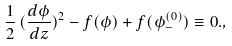Convert formula to latex. <formula><loc_0><loc_0><loc_500><loc_500>\frac { 1 } { 2 } \, ( \frac { d \phi } { d z } ) ^ { 2 } - f ( \phi ) + f ( \phi _ { - } ^ { ( 0 ) } ) \equiv 0 . ,</formula> 